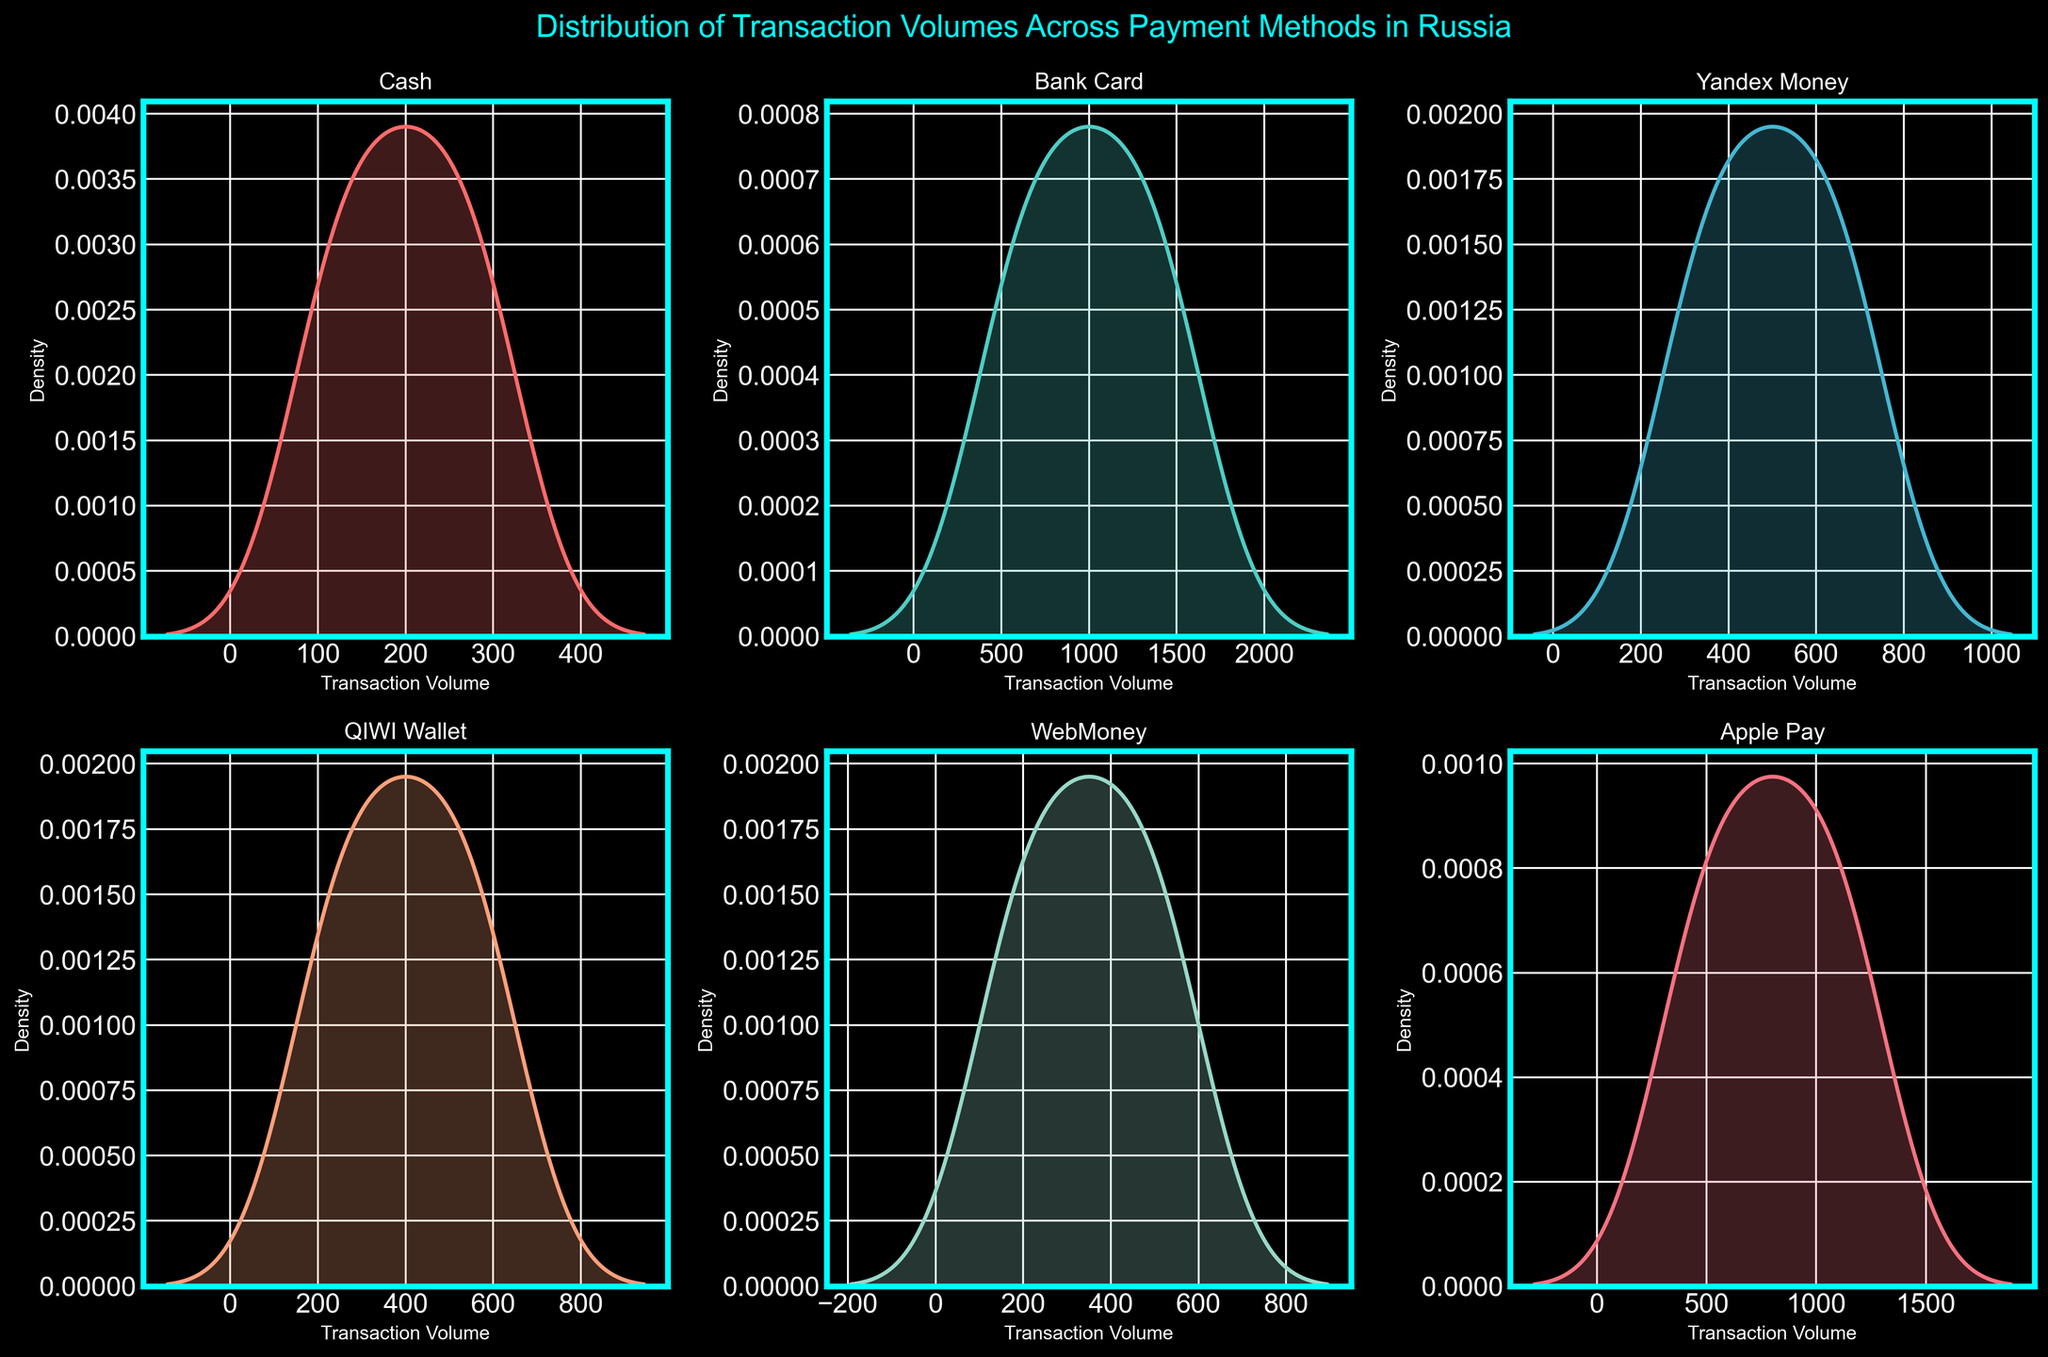Which payment method has the highest peak in its density plot? By looking at the density plots, we can see that the peak height represents the mode transaction volume of each payment method. The highest peak value indicates the payment method with the most frequent transaction volume.
Answer: Bank Card Which payment method has the lowest transaction volume spread? The spread of the density plot shows the variability of transaction volumes. The payment method with the narrowest spread has the least variability.
Answer: Cash What is the title of the figure? The title is typically at the top of the figure and provides an overall description of what the figure is depicting. For this plot, it is mentioned explicitly in the code as "Distribution of Transaction Volumes Across Payment Methods in Russia".
Answer: Distribution of Transaction Volumes Across Payment Methods in Russia Which payment methods show density peaks around 500 transaction volume? By examining the density plots, we identify the payment methods with density peaks near 500.
Answer: QIWI Wallet, Yandex Money, and Apple Pay Compare the transaction volume distributions of "Yandex Money" and "Apple Pay". Which one has a wider range? Comparing the width of the density plots for "Apple Pay" and "Yandex Money", we see that "Apple Pay" has a larger spread of transaction volumes, indicating a wider range.
Answer: Apple Pay Which axis represents the transaction volume in the subplots? The x-axis in each density plot represents transaction volume, as it is labeled accordingly.
Answer: X-axis For WebMoney, what transaction volume has the highest density? The highest point on the density plot for WebMoney indicates the most common transaction volume.
Answer: 250 How do the density plots visually differentiate the payment methods? The plots use different colors and individual subplots to differentiate between payment methods. Each subplot is titled with the respective payment method's name.
Answer: Different colors, individual subplots Among all payment methods, which one has the least common transaction volume above 1000? Since most density plots do not extend beyond 1000 except for "Bank Card" and "Apple Pay", and "Bank Card" shows frequent transactions above this value, "Bank Card" is the likely answer.
Answer: Not applicable (None except Bank Card) Which payment method shows two distinct peaks in its transaction volume distribution, indicating bimodal distribution? Observing the density plots, "Apple Pay" shows two peaks, suggesting a bimodal distribution indicating two frequent transaction volumes.
Answer: Apple Pay 